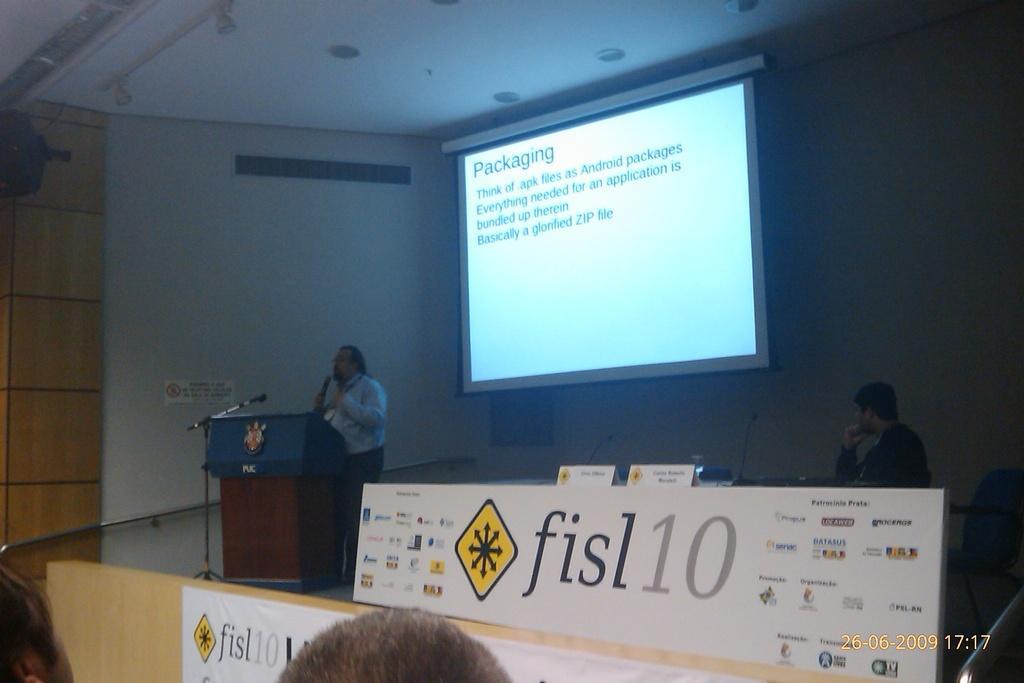Could you give a brief overview of what you see in this image? In this image I can see a person standing in front of the podium. I can see a mic,stand and white color board on the stage. Back I can see a screen and white color wall. 